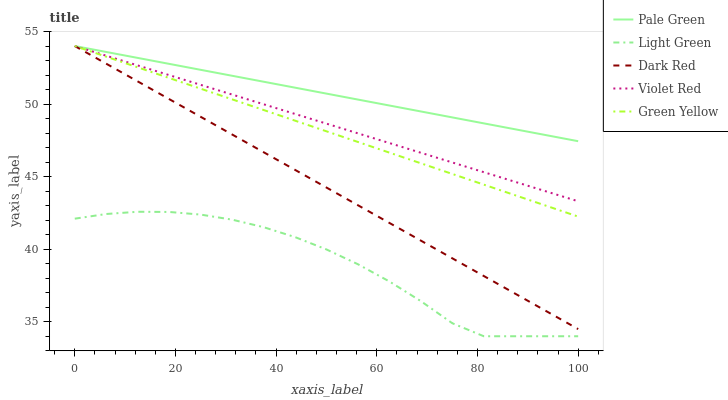Does Light Green have the minimum area under the curve?
Answer yes or no. Yes. Does Pale Green have the maximum area under the curve?
Answer yes or no. Yes. Does Violet Red have the minimum area under the curve?
Answer yes or no. No. Does Violet Red have the maximum area under the curve?
Answer yes or no. No. Is Dark Red the smoothest?
Answer yes or no. Yes. Is Light Green the roughest?
Answer yes or no. Yes. Is Violet Red the smoothest?
Answer yes or no. No. Is Violet Red the roughest?
Answer yes or no. No. Does Violet Red have the lowest value?
Answer yes or no. No. Does Green Yellow have the highest value?
Answer yes or no. Yes. Does Light Green have the highest value?
Answer yes or no. No. Is Light Green less than Violet Red?
Answer yes or no. Yes. Is Violet Red greater than Light Green?
Answer yes or no. Yes. Does Dark Red intersect Green Yellow?
Answer yes or no. Yes. Is Dark Red less than Green Yellow?
Answer yes or no. No. Is Dark Red greater than Green Yellow?
Answer yes or no. No. Does Light Green intersect Violet Red?
Answer yes or no. No. 